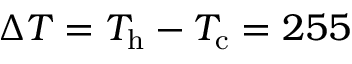<formula> <loc_0><loc_0><loc_500><loc_500>\Delta T = T _ { h } - T _ { c } = 2 5 5</formula> 